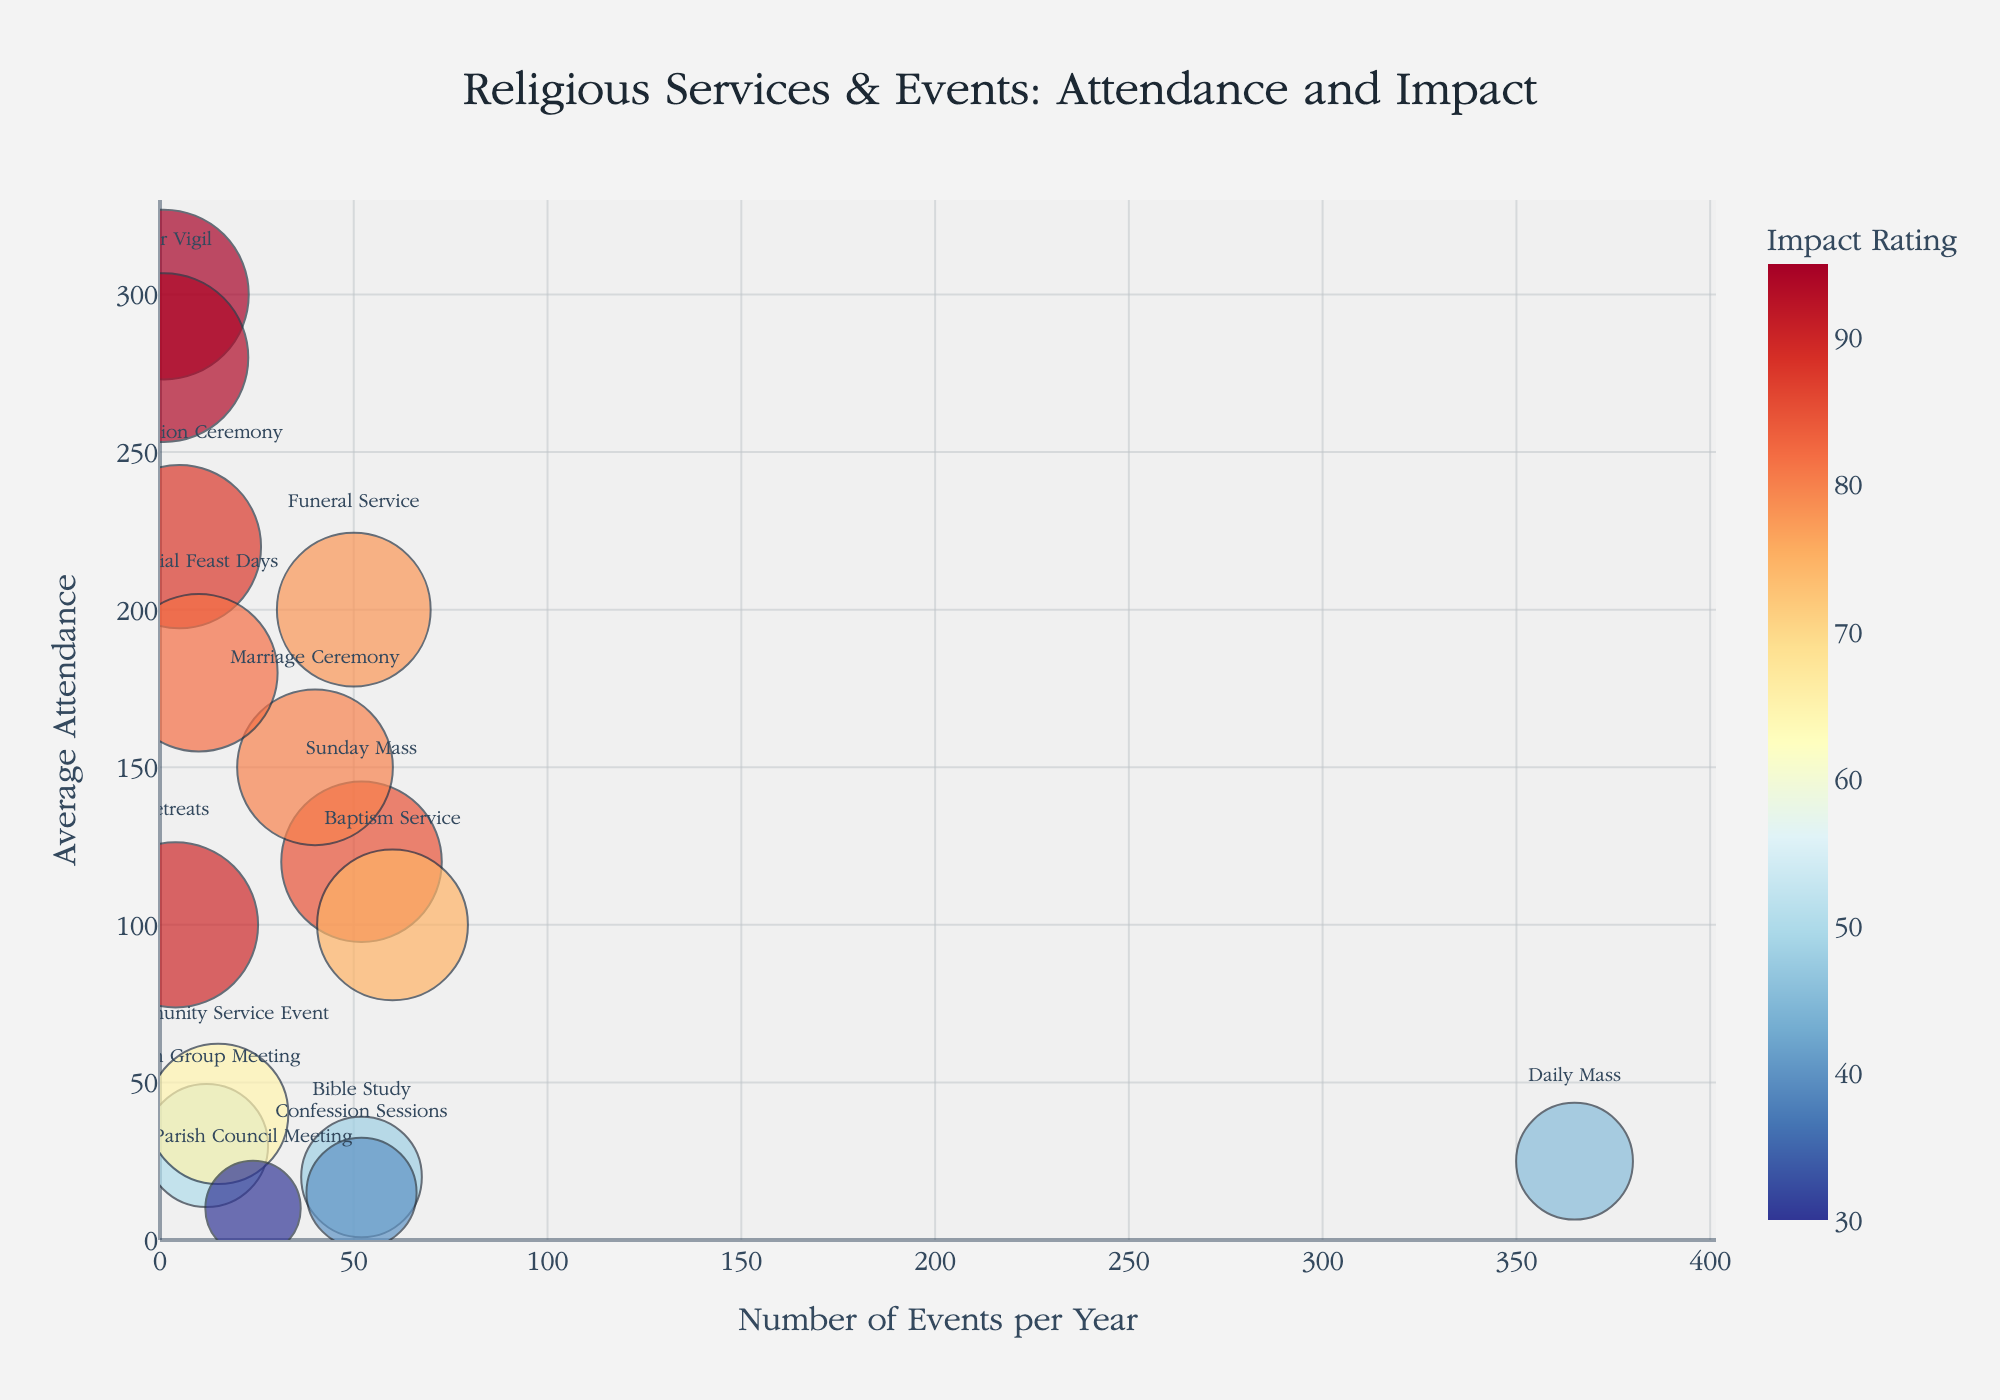How many events per year does the "Daily Mass" have? Find "Daily Mass" on the chart and look at the x-axis value.
Answer: 365 Which service has the highest average attendance? Look for the bubble at the highest point on the y-axis. The service type associated with it is "Christmas Mass."
Answer: Christmas Mass What is the average attendance of "Youth Group Meeting" compared to "Bible Study"? Find "Youth Group Meeting" and "Bible Study" on the chart and read their y-axis values. "Youth Group Meeting" has an average attendance of 30, while "Bible Study" has 20.
Answer: Youth Group Meeting has higher average attendance Which service has an impact rating between 85 and 90 and also occurs more than 10 times a year? Identify the bubbles within the impact rating range of 85-90 and count the ones that have x-axis values greater than 10. "Sunday Mass" fits these criteria.
Answer: Sunday Mass How many services have an average attendance less than 50? Count the number of bubbles located below 50 on the y-axis. "Daily Mass," "Youth Group Meeting," "Bible Study," "Community Service Event," "Confession Sessions," and "Parish Council Meeting" fit this criteria.
Answer: 6 Which service has the largest bubble size? Identify the service with the largest bubble in the chart. "Christmas Mass" has the largest impact rating and thus the largest bubble.
Answer: Christmas Mass What is the relationship between "Number of Events per Year" and "Average Attendance" for "Funeral Service" and "Marriage Ceremony"? Compare the x- and y-axis values for both services. "Funeral Service" has 50 events per year with an average attendance of 200, while "Marriage Ceremony" has 40 events per year with an average attendance of 150.
Answer: Funeral Service has higher average attendance but occurs more frequently than Marriage Ceremony What’s the average impact rating of services occurring only once per year? Find the bubbles for services occurring once a year: "Christmas Mass" (95) and "Easter Vigil" (94). Calculate their average impact rating: (95 + 94) / 2 = 94.5.
Answer: 94.5 